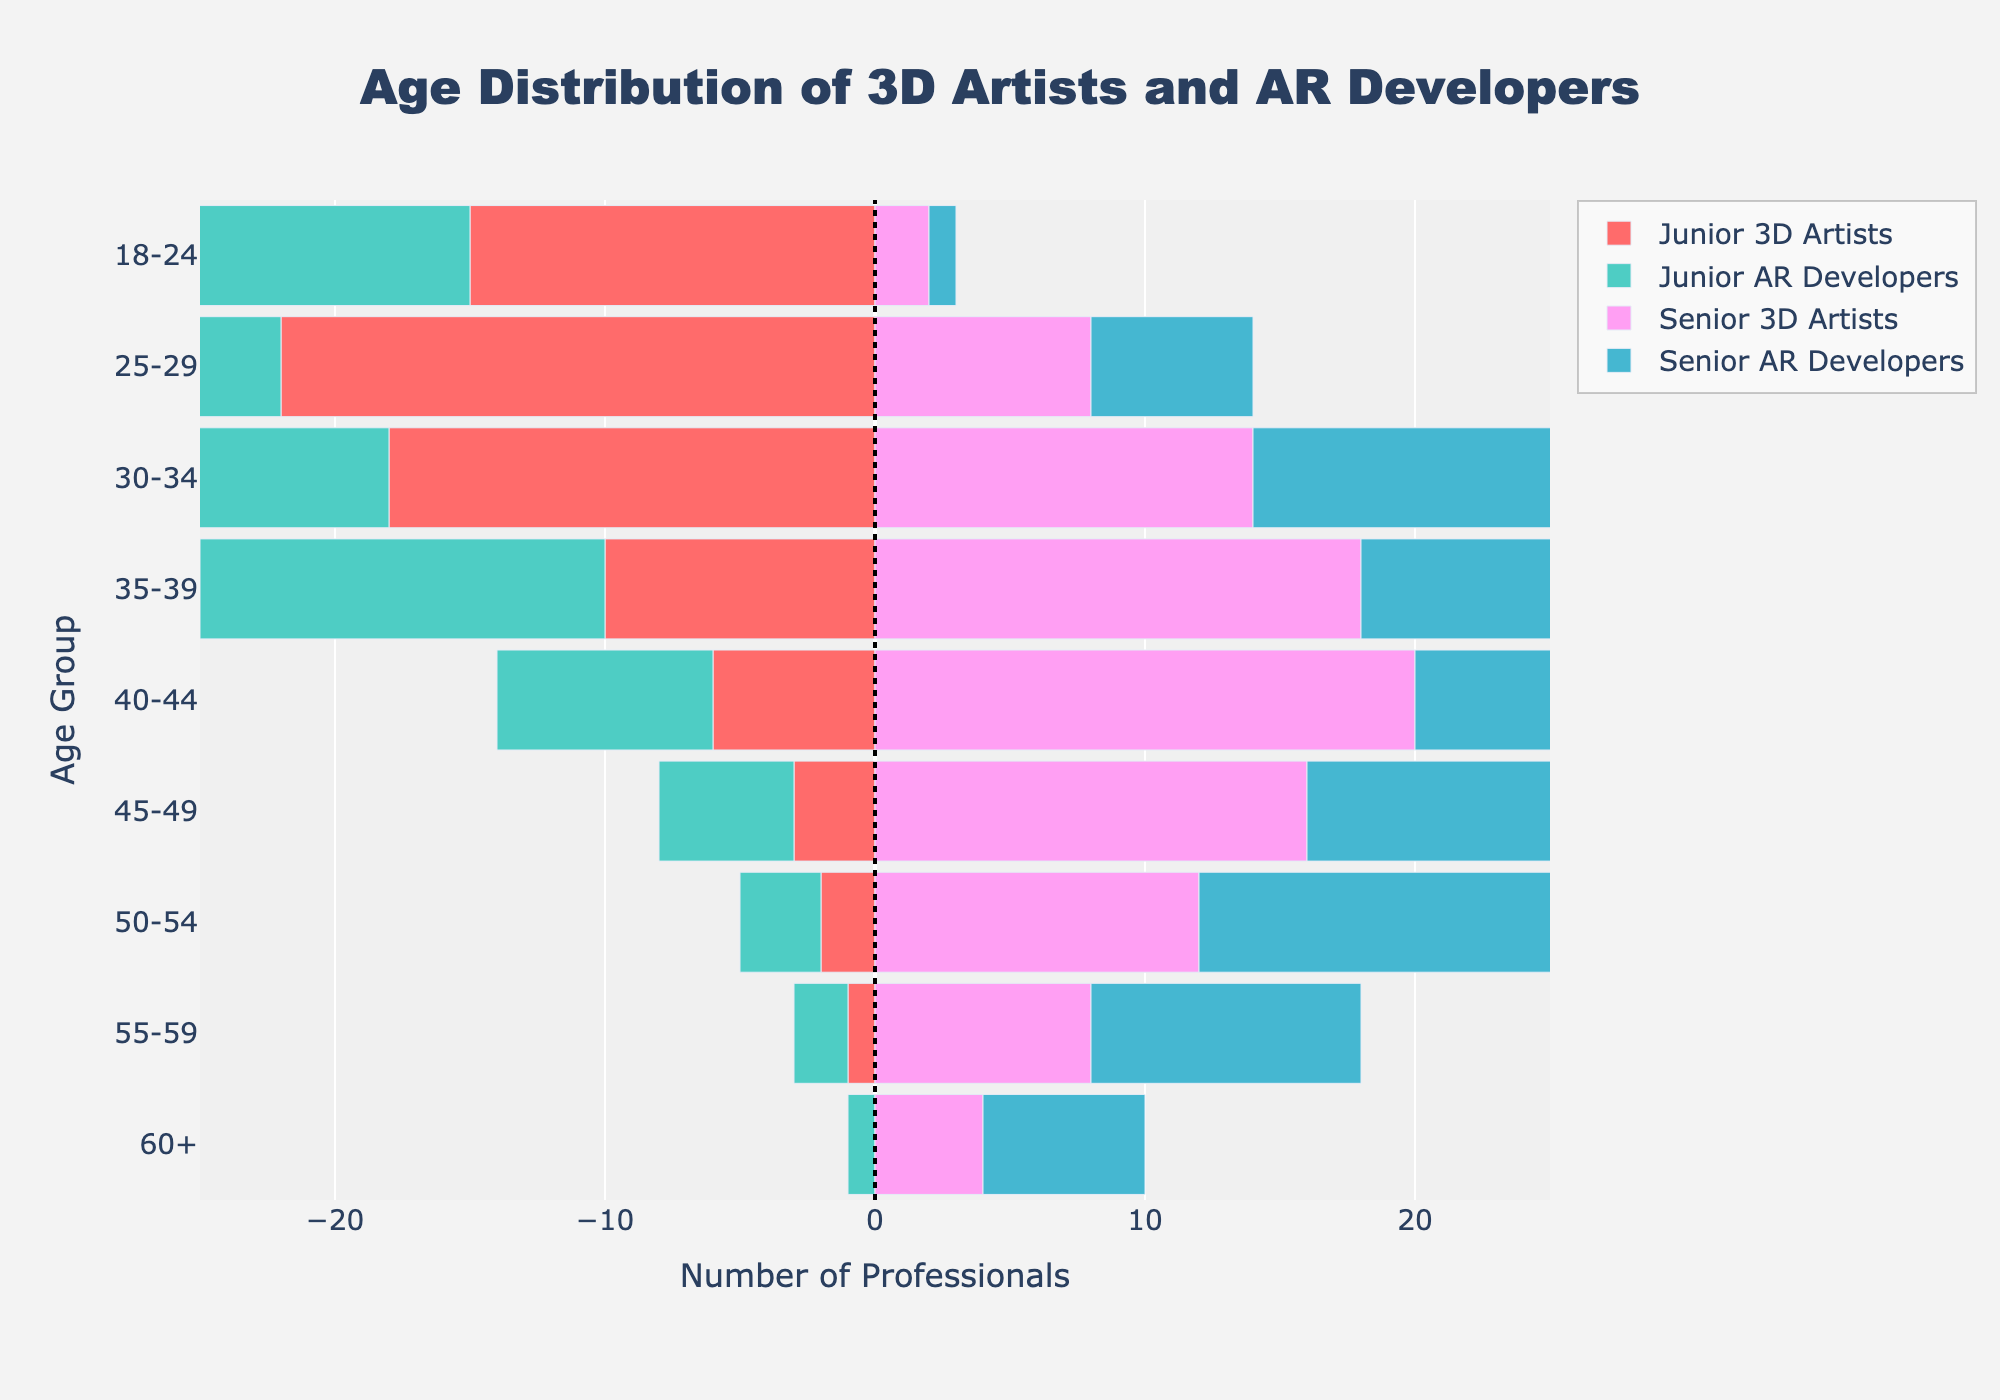How many age groups are considered in this figure? The figure shows nine age groups listed on the vertical axis: 18-24, 25-29, 30-34, 35-39, 40-44, 45-49, 50-54, 55-59, and 60+.
Answer: 9 Which age group has the highest number of Junior 3D Artists? The age group with the highest bar extending to the left for Junior 3D Artists is the 25-29 group.
Answer: 25-29 In the 40-44 age group, how many professionals are Senior AR Developers? By looking at the bar for Senior AR Developers in the 40-44 age group, the number is 22.
Answer: 22 Which group has more professionals aged 30-34, Junior AR Developers or Junior 3D Artists? In the age group 30-34, the bar length for Junior AR Developers is longer than that for Junior 3D Artists, showing 20 versus 18.
Answer: Junior AR Developers What is the total number of Senior professionals in the 45-49 age group (include both 3D Artists and AR Developers)? By adding 16 Senior 3D Artists and 18 Senior AR Developers in the 45-49 age group, the total is 34.
Answer: 34 How does the distribution of Junior AR Developers in the 25-29 age group compare to Junior 3D Artists in the same age group? Comparing the lengths of the bars for Junior AR Developers and Junior 3D Artists in the 25-29 age group, Junior AR Developers have 18 professionals while Junior 3D Artists have 22.
Answer: Junior 3D Artists have more In which age group is the number of Senior 3D Artists equal to the number of Senior AR Developers? The length of the bars for Senior 3D Artists and Senior AR Developers are the same in the 35-39 age group, both showing 16.
Answer: 35-39 What is the difference in number between Senior 3D Artists and Junior 3D Artists in the 40-44 age group? The 40-44 age group shows 20 Senior 3D Artists and 6 Junior 3D Artists, resulting in a difference of 20 - 6 = 14.
Answer: 14 Looking at the entire chart, which group has the lowest numbers across all age groups? By comparing all the bars, Junior 3D Artists in the 60+ age group are the lowest with 0 professionals.
Answer: Junior 3D Artists in 60+ Which age group sees more professionals in Senior AR Developers compared to Junior AR Developers? The 40-44, 45-49, 50-54, and 55-59 age groups all have more Senior AR Developers compared to Junior AR Developers when comparing their bar lengths.
Answer: 40-44, 45-49, 50-54, 55-59 